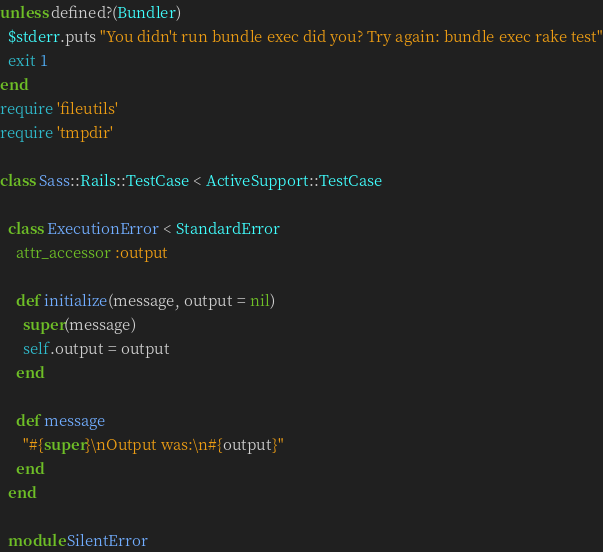<code> <loc_0><loc_0><loc_500><loc_500><_Ruby_>unless defined?(Bundler)
  $stderr.puts "You didn't run bundle exec did you? Try again: bundle exec rake test"
  exit 1
end
require 'fileutils'
require 'tmpdir'

class Sass::Rails::TestCase < ActiveSupport::TestCase

  class ExecutionError < StandardError
    attr_accessor :output

    def initialize(message, output = nil)
      super(message)
      self.output = output
    end

    def message
      "#{super}\nOutput was:\n#{output}"
    end
  end

  module SilentError</code> 